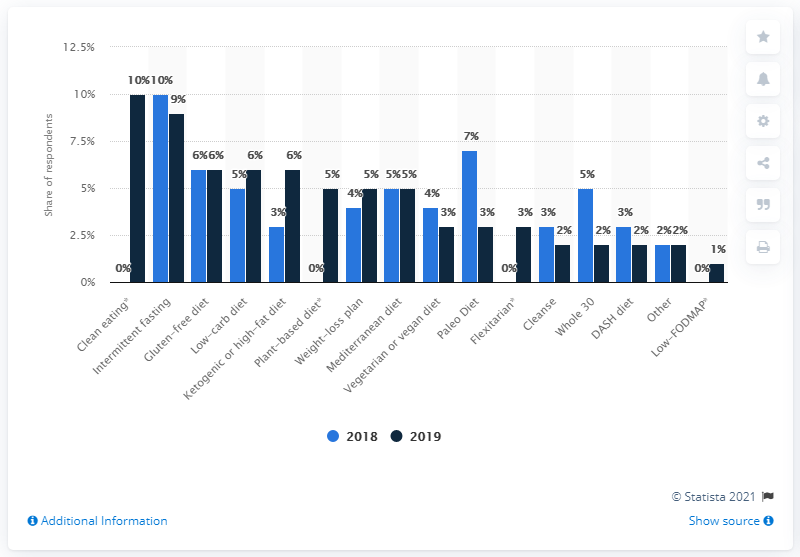List a handful of essential elements in this visual. In the year 2018, high-fat diets saw the biggest increase in adoption in the United States. 